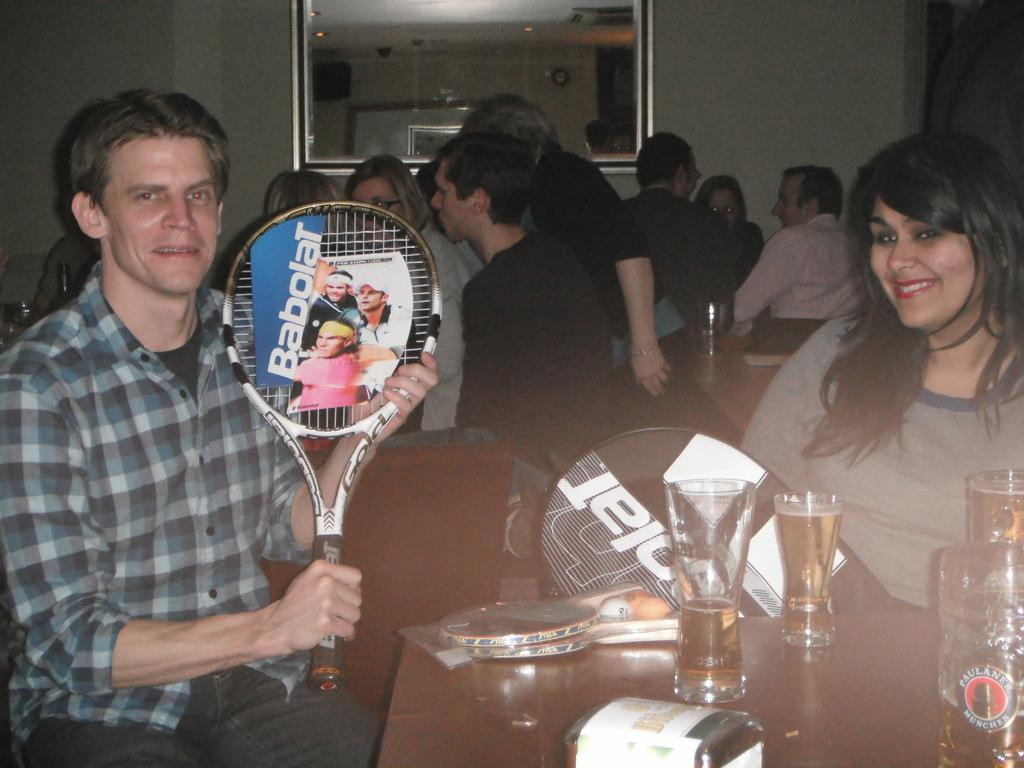How many people are in the image? There is a group of people in the image. What are the people doing in the image? The people are sitting on chairs. What is on the table in the image? There is a glass on the table. What object is the man holding in the image? The man is holding a racket. What color is the brick wall behind the people in the image? There is no brick wall present in the image. Is it raining in the image? The image does not show any indication of rain. 